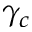Convert formula to latex. <formula><loc_0><loc_0><loc_500><loc_500>\gamma _ { c }</formula> 